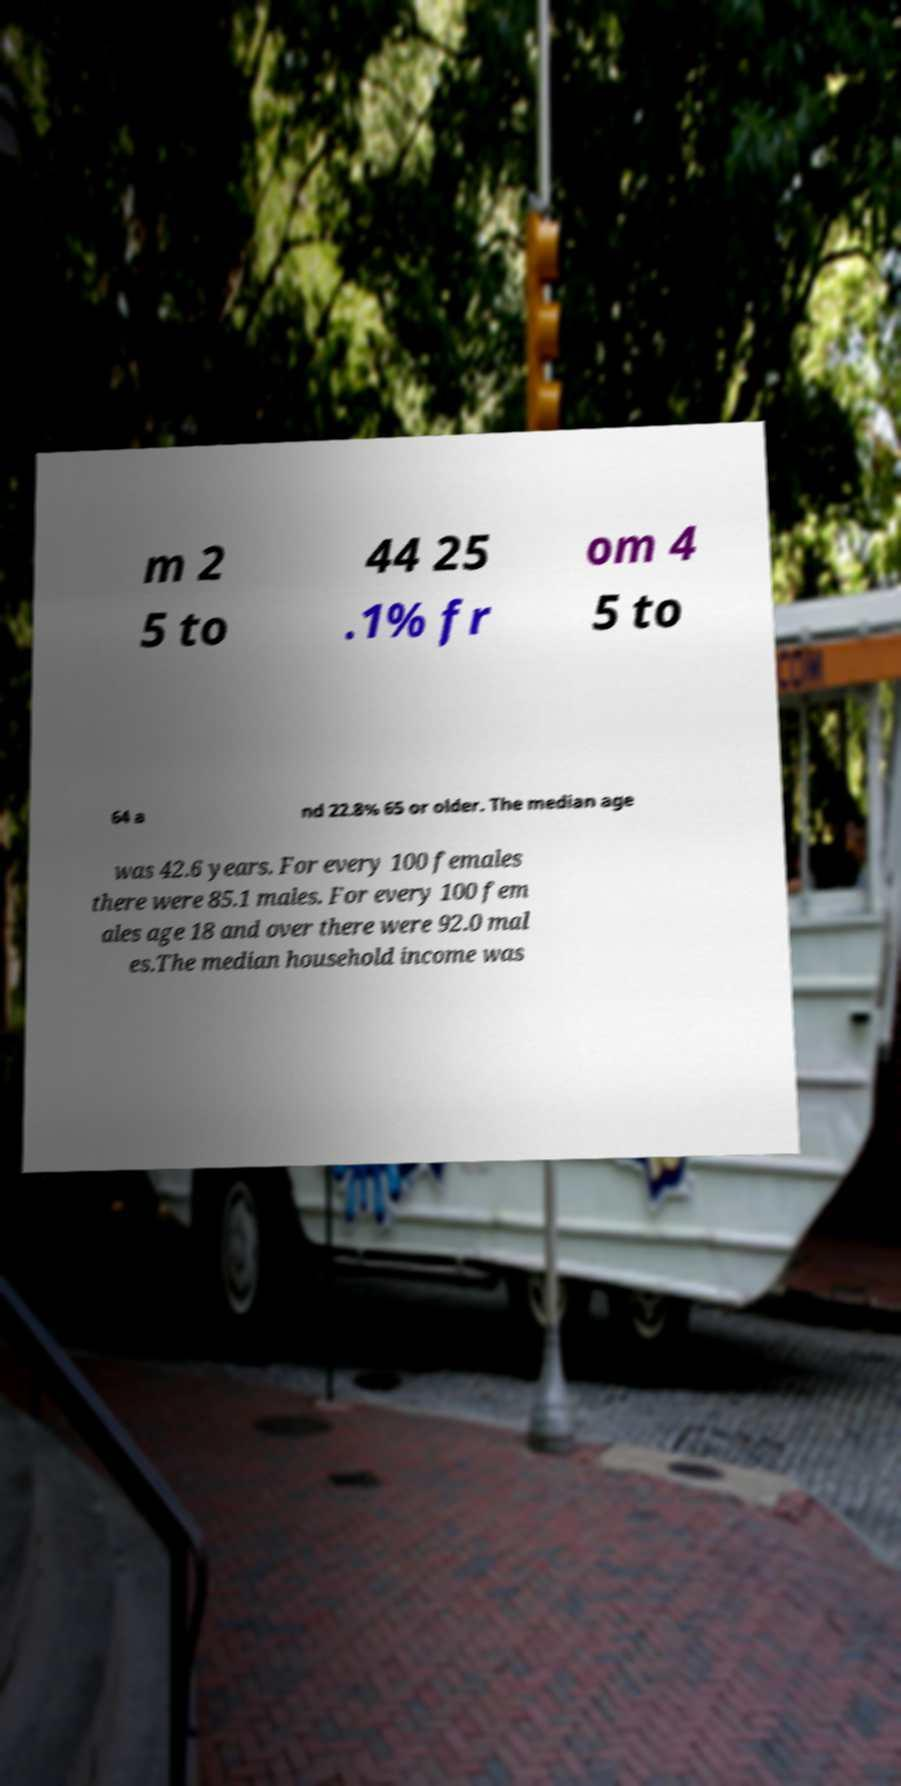What messages or text are displayed in this image? I need them in a readable, typed format. m 2 5 to 44 25 .1% fr om 4 5 to 64 a nd 22.8% 65 or older. The median age was 42.6 years. For every 100 females there were 85.1 males. For every 100 fem ales age 18 and over there were 92.0 mal es.The median household income was 